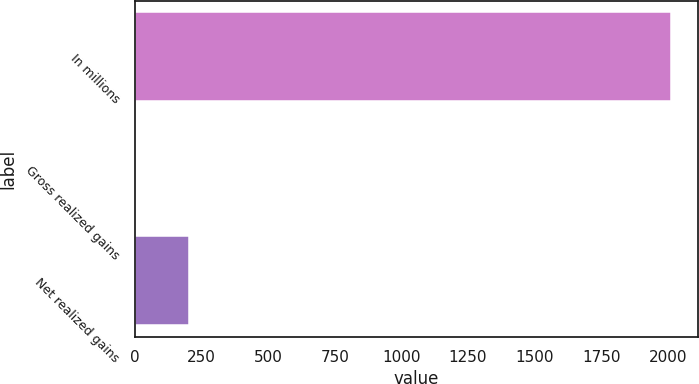Convert chart to OTSL. <chart><loc_0><loc_0><loc_500><loc_500><bar_chart><fcel>In millions<fcel>Gross realized gains<fcel>Net realized gains<nl><fcel>2013<fcel>0.9<fcel>202.11<nl></chart> 